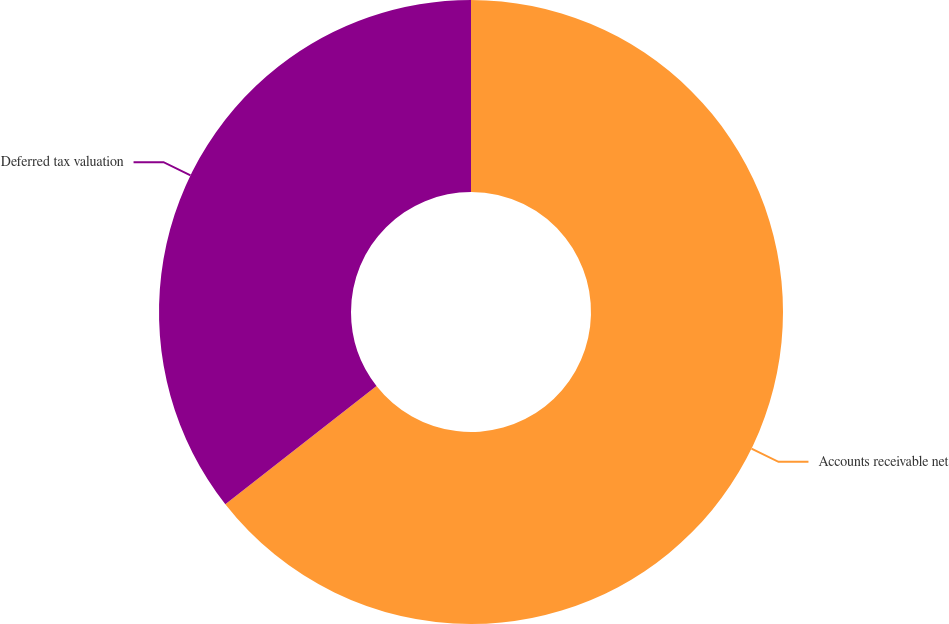Convert chart. <chart><loc_0><loc_0><loc_500><loc_500><pie_chart><fcel>Accounts receivable net<fcel>Deferred tax valuation<nl><fcel>64.43%<fcel>35.57%<nl></chart> 